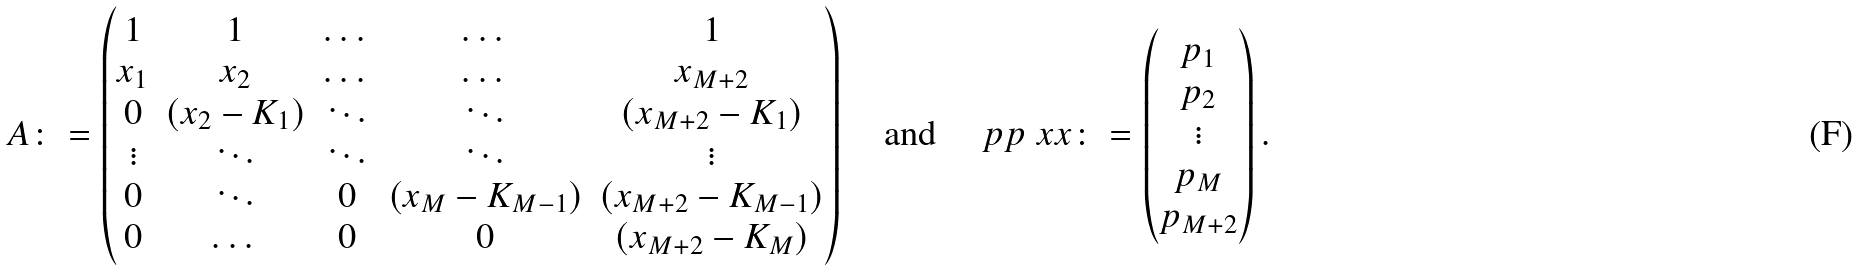Convert formula to latex. <formula><loc_0><loc_0><loc_500><loc_500>\AA A \colon = \begin{pmatrix} 1 & 1 & \dots & \dots & 1 \\ x _ { 1 } & x _ { 2 } & \dots & \dots & x _ { M + 2 } \\ 0 & ( x _ { 2 } - K _ { 1 } ) & \ddots & \ddots & ( x _ { M + 2 } - K _ { 1 } ) \\ \vdots & \ddots & \ddots & \ddots & \vdots \\ 0 & \ddots & 0 & ( x _ { M } - K _ { M - 1 } ) & ( x _ { M + 2 } - K _ { M - 1 } ) \\ 0 & \dots & 0 & 0 & ( x _ { M + 2 } - K _ { M } ) \end{pmatrix} \quad \text {and} \quad \ p p ^ { \ } x x \colon = \begin{pmatrix} p _ { 1 } \\ p _ { 2 } \\ \vdots \\ p _ { M } \\ p _ { M + 2 } \end{pmatrix} .</formula> 